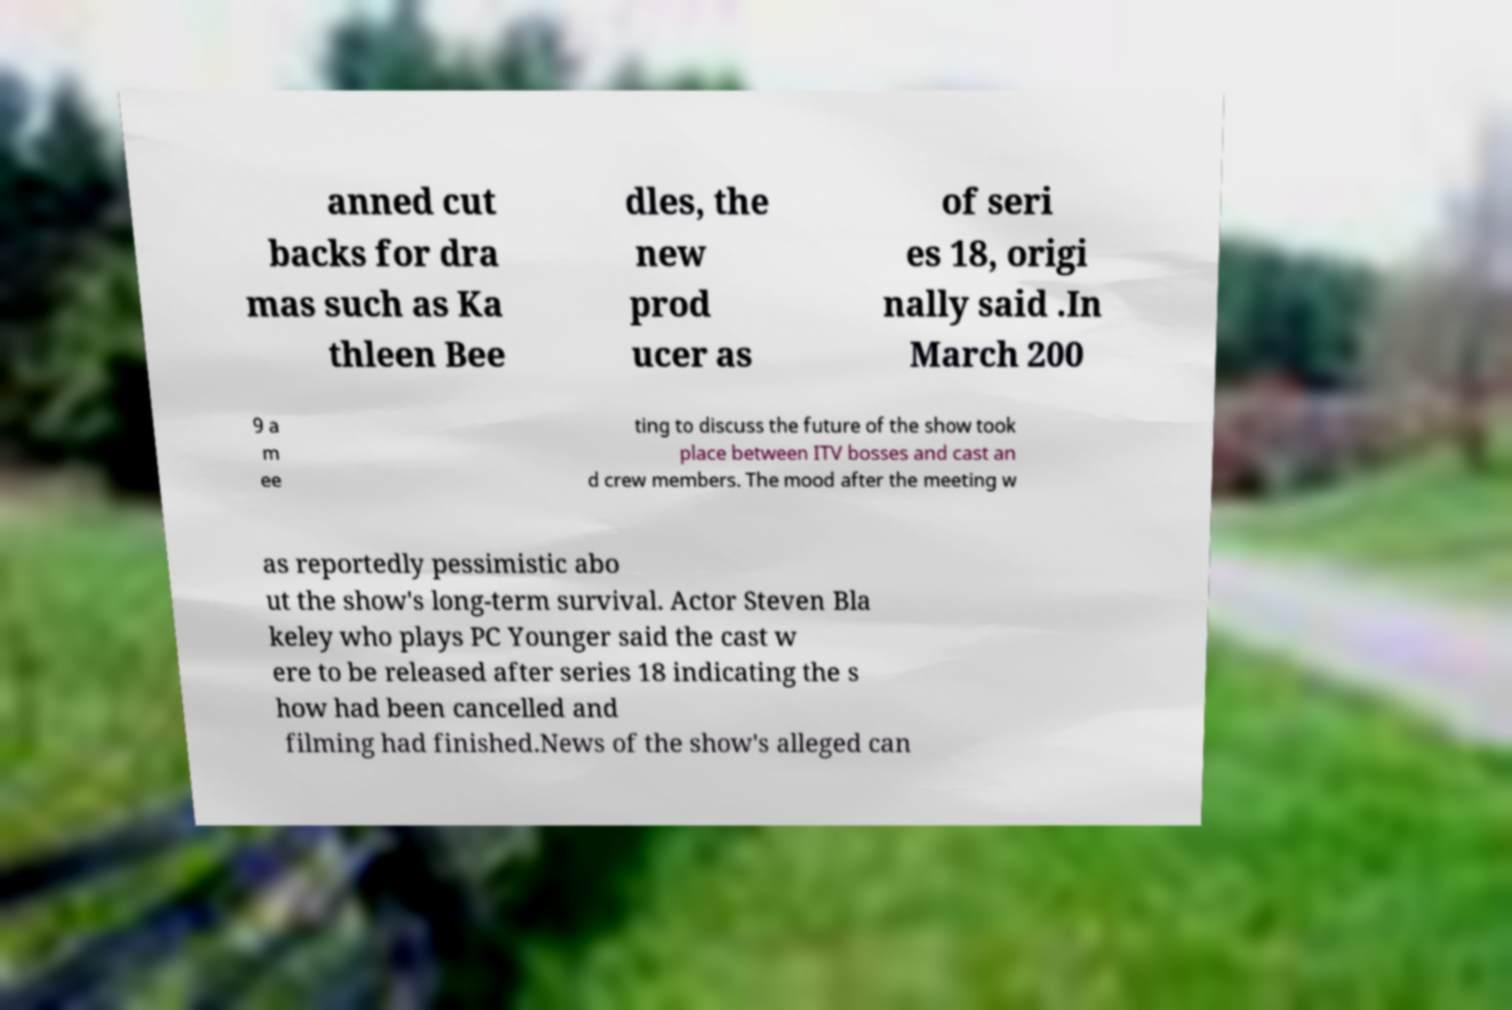What messages or text are displayed in this image? I need them in a readable, typed format. anned cut backs for dra mas such as Ka thleen Bee dles, the new prod ucer as of seri es 18, origi nally said .In March 200 9 a m ee ting to discuss the future of the show took place between ITV bosses and cast an d crew members. The mood after the meeting w as reportedly pessimistic abo ut the show's long-term survival. Actor Steven Bla keley who plays PC Younger said the cast w ere to be released after series 18 indicating the s how had been cancelled and filming had finished.News of the show's alleged can 